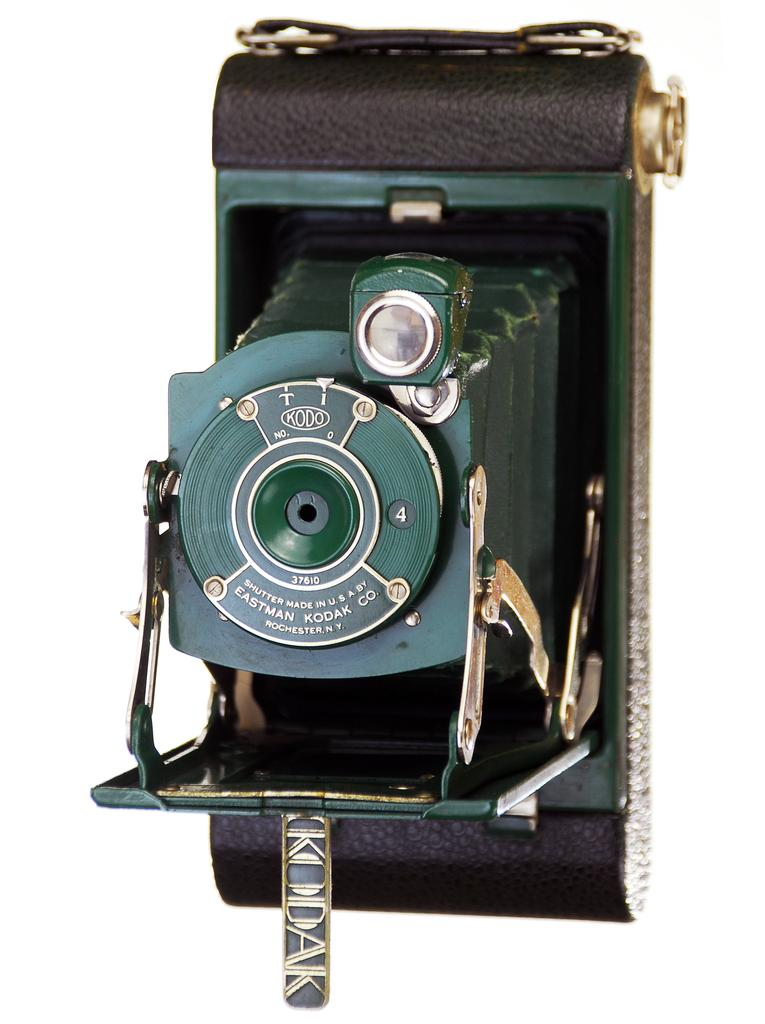What type of object is the main subject in the image? There is an old camera in the image. What type of reward does the crow receive for cleaning the maid's room in the image? There is no crow or maid present in the image, and therefore no such activity or reward can be observed. 